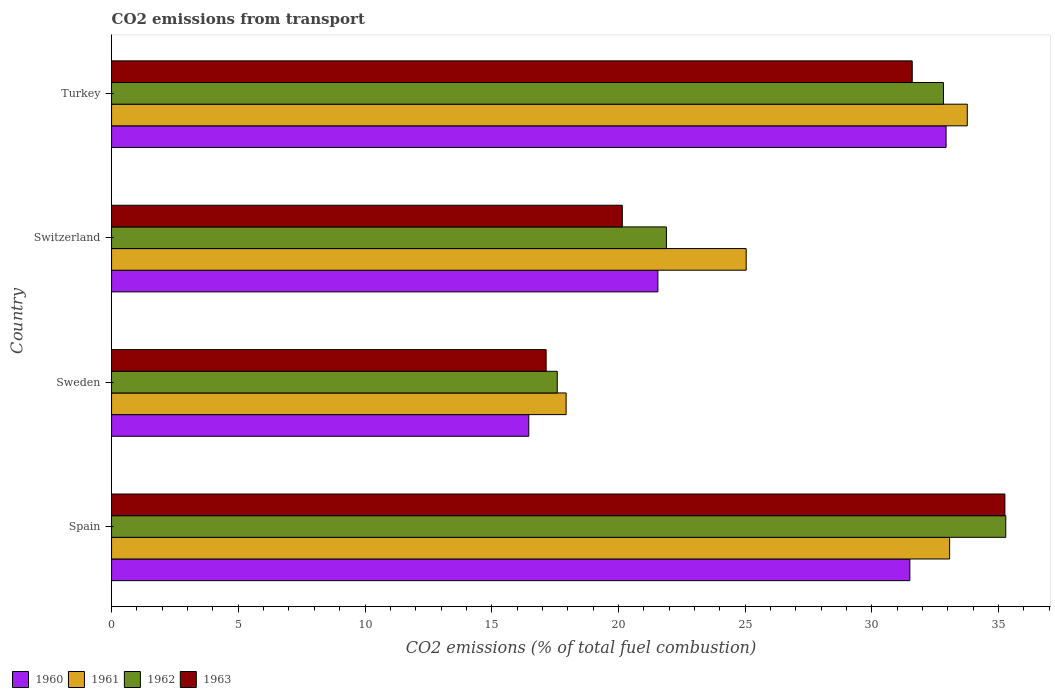How many groups of bars are there?
Make the answer very short. 4. How many bars are there on the 2nd tick from the top?
Your answer should be compact. 4. What is the total CO2 emitted in 1963 in Switzerland?
Your response must be concise. 20.15. Across all countries, what is the maximum total CO2 emitted in 1962?
Provide a succinct answer. 35.28. Across all countries, what is the minimum total CO2 emitted in 1961?
Offer a very short reply. 17.94. What is the total total CO2 emitted in 1960 in the graph?
Give a very brief answer. 102.45. What is the difference between the total CO2 emitted in 1961 in Spain and that in Sweden?
Give a very brief answer. 15.13. What is the difference between the total CO2 emitted in 1962 in Switzerland and the total CO2 emitted in 1960 in Sweden?
Ensure brevity in your answer.  5.43. What is the average total CO2 emitted in 1961 per country?
Ensure brevity in your answer.  27.45. What is the difference between the total CO2 emitted in 1963 and total CO2 emitted in 1960 in Turkey?
Your answer should be very brief. -1.34. What is the ratio of the total CO2 emitted in 1963 in Switzerland to that in Turkey?
Keep it short and to the point. 0.64. What is the difference between the highest and the second highest total CO2 emitted in 1961?
Provide a short and direct response. 0.7. What is the difference between the highest and the lowest total CO2 emitted in 1961?
Give a very brief answer. 15.83. In how many countries, is the total CO2 emitted in 1961 greater than the average total CO2 emitted in 1961 taken over all countries?
Offer a terse response. 2. Is the sum of the total CO2 emitted in 1963 in Spain and Switzerland greater than the maximum total CO2 emitted in 1962 across all countries?
Ensure brevity in your answer.  Yes. Is it the case that in every country, the sum of the total CO2 emitted in 1962 and total CO2 emitted in 1961 is greater than the total CO2 emitted in 1963?
Ensure brevity in your answer.  Yes. How many bars are there?
Provide a short and direct response. 16. Are all the bars in the graph horizontal?
Your answer should be very brief. Yes. What is the difference between two consecutive major ticks on the X-axis?
Ensure brevity in your answer.  5. Does the graph contain any zero values?
Offer a very short reply. No. Does the graph contain grids?
Your response must be concise. No. Where does the legend appear in the graph?
Give a very brief answer. Bottom left. What is the title of the graph?
Your response must be concise. CO2 emissions from transport. What is the label or title of the X-axis?
Your answer should be compact. CO2 emissions (% of total fuel combustion). What is the CO2 emissions (% of total fuel combustion) of 1960 in Spain?
Provide a short and direct response. 31.5. What is the CO2 emissions (% of total fuel combustion) of 1961 in Spain?
Give a very brief answer. 33.07. What is the CO2 emissions (% of total fuel combustion) in 1962 in Spain?
Keep it short and to the point. 35.28. What is the CO2 emissions (% of total fuel combustion) in 1963 in Spain?
Give a very brief answer. 35.25. What is the CO2 emissions (% of total fuel combustion) in 1960 in Sweden?
Offer a very short reply. 16.46. What is the CO2 emissions (% of total fuel combustion) in 1961 in Sweden?
Give a very brief answer. 17.94. What is the CO2 emissions (% of total fuel combustion) in 1962 in Sweden?
Keep it short and to the point. 17.59. What is the CO2 emissions (% of total fuel combustion) in 1963 in Sweden?
Make the answer very short. 17.15. What is the CO2 emissions (% of total fuel combustion) of 1960 in Switzerland?
Your answer should be very brief. 21.56. What is the CO2 emissions (% of total fuel combustion) in 1961 in Switzerland?
Give a very brief answer. 25.04. What is the CO2 emissions (% of total fuel combustion) in 1962 in Switzerland?
Provide a short and direct response. 21.89. What is the CO2 emissions (% of total fuel combustion) of 1963 in Switzerland?
Provide a succinct answer. 20.15. What is the CO2 emissions (% of total fuel combustion) in 1960 in Turkey?
Provide a succinct answer. 32.93. What is the CO2 emissions (% of total fuel combustion) of 1961 in Turkey?
Offer a terse response. 33.76. What is the CO2 emissions (% of total fuel combustion) in 1962 in Turkey?
Provide a short and direct response. 32.82. What is the CO2 emissions (% of total fuel combustion) in 1963 in Turkey?
Your answer should be very brief. 31.59. Across all countries, what is the maximum CO2 emissions (% of total fuel combustion) in 1960?
Ensure brevity in your answer.  32.93. Across all countries, what is the maximum CO2 emissions (% of total fuel combustion) of 1961?
Provide a succinct answer. 33.76. Across all countries, what is the maximum CO2 emissions (% of total fuel combustion) of 1962?
Offer a terse response. 35.28. Across all countries, what is the maximum CO2 emissions (% of total fuel combustion) in 1963?
Provide a short and direct response. 35.25. Across all countries, what is the minimum CO2 emissions (% of total fuel combustion) of 1960?
Your response must be concise. 16.46. Across all countries, what is the minimum CO2 emissions (% of total fuel combustion) of 1961?
Make the answer very short. 17.94. Across all countries, what is the minimum CO2 emissions (% of total fuel combustion) in 1962?
Your answer should be compact. 17.59. Across all countries, what is the minimum CO2 emissions (% of total fuel combustion) of 1963?
Provide a short and direct response. 17.15. What is the total CO2 emissions (% of total fuel combustion) of 1960 in the graph?
Keep it short and to the point. 102.45. What is the total CO2 emissions (% of total fuel combustion) of 1961 in the graph?
Offer a terse response. 109.81. What is the total CO2 emissions (% of total fuel combustion) in 1962 in the graph?
Make the answer very short. 107.59. What is the total CO2 emissions (% of total fuel combustion) of 1963 in the graph?
Give a very brief answer. 104.14. What is the difference between the CO2 emissions (% of total fuel combustion) in 1960 in Spain and that in Sweden?
Make the answer very short. 15.04. What is the difference between the CO2 emissions (% of total fuel combustion) of 1961 in Spain and that in Sweden?
Your response must be concise. 15.13. What is the difference between the CO2 emissions (% of total fuel combustion) in 1962 in Spain and that in Sweden?
Offer a very short reply. 17.7. What is the difference between the CO2 emissions (% of total fuel combustion) of 1963 in Spain and that in Sweden?
Your response must be concise. 18.1. What is the difference between the CO2 emissions (% of total fuel combustion) of 1960 in Spain and that in Switzerland?
Provide a short and direct response. 9.94. What is the difference between the CO2 emissions (% of total fuel combustion) of 1961 in Spain and that in Switzerland?
Give a very brief answer. 8.03. What is the difference between the CO2 emissions (% of total fuel combustion) of 1962 in Spain and that in Switzerland?
Ensure brevity in your answer.  13.39. What is the difference between the CO2 emissions (% of total fuel combustion) in 1963 in Spain and that in Switzerland?
Provide a succinct answer. 15.1. What is the difference between the CO2 emissions (% of total fuel combustion) in 1960 in Spain and that in Turkey?
Your answer should be compact. -1.43. What is the difference between the CO2 emissions (% of total fuel combustion) of 1961 in Spain and that in Turkey?
Provide a short and direct response. -0.7. What is the difference between the CO2 emissions (% of total fuel combustion) of 1962 in Spain and that in Turkey?
Ensure brevity in your answer.  2.46. What is the difference between the CO2 emissions (% of total fuel combustion) in 1963 in Spain and that in Turkey?
Provide a short and direct response. 3.66. What is the difference between the CO2 emissions (% of total fuel combustion) of 1960 in Sweden and that in Switzerland?
Make the answer very short. -5.09. What is the difference between the CO2 emissions (% of total fuel combustion) in 1961 in Sweden and that in Switzerland?
Offer a terse response. -7.1. What is the difference between the CO2 emissions (% of total fuel combustion) in 1962 in Sweden and that in Switzerland?
Provide a short and direct response. -4.31. What is the difference between the CO2 emissions (% of total fuel combustion) in 1963 in Sweden and that in Switzerland?
Provide a succinct answer. -3.01. What is the difference between the CO2 emissions (% of total fuel combustion) in 1960 in Sweden and that in Turkey?
Offer a terse response. -16.47. What is the difference between the CO2 emissions (% of total fuel combustion) of 1961 in Sweden and that in Turkey?
Your response must be concise. -15.83. What is the difference between the CO2 emissions (% of total fuel combustion) of 1962 in Sweden and that in Turkey?
Offer a terse response. -15.24. What is the difference between the CO2 emissions (% of total fuel combustion) in 1963 in Sweden and that in Turkey?
Ensure brevity in your answer.  -14.44. What is the difference between the CO2 emissions (% of total fuel combustion) in 1960 in Switzerland and that in Turkey?
Your answer should be compact. -11.37. What is the difference between the CO2 emissions (% of total fuel combustion) in 1961 in Switzerland and that in Turkey?
Give a very brief answer. -8.72. What is the difference between the CO2 emissions (% of total fuel combustion) of 1962 in Switzerland and that in Turkey?
Make the answer very short. -10.93. What is the difference between the CO2 emissions (% of total fuel combustion) in 1963 in Switzerland and that in Turkey?
Keep it short and to the point. -11.44. What is the difference between the CO2 emissions (% of total fuel combustion) of 1960 in Spain and the CO2 emissions (% of total fuel combustion) of 1961 in Sweden?
Provide a succinct answer. 13.56. What is the difference between the CO2 emissions (% of total fuel combustion) of 1960 in Spain and the CO2 emissions (% of total fuel combustion) of 1962 in Sweden?
Your answer should be compact. 13.91. What is the difference between the CO2 emissions (% of total fuel combustion) of 1960 in Spain and the CO2 emissions (% of total fuel combustion) of 1963 in Sweden?
Your answer should be very brief. 14.35. What is the difference between the CO2 emissions (% of total fuel combustion) in 1961 in Spain and the CO2 emissions (% of total fuel combustion) in 1962 in Sweden?
Provide a short and direct response. 15.48. What is the difference between the CO2 emissions (% of total fuel combustion) in 1961 in Spain and the CO2 emissions (% of total fuel combustion) in 1963 in Sweden?
Provide a short and direct response. 15.92. What is the difference between the CO2 emissions (% of total fuel combustion) of 1962 in Spain and the CO2 emissions (% of total fuel combustion) of 1963 in Sweden?
Offer a very short reply. 18.14. What is the difference between the CO2 emissions (% of total fuel combustion) in 1960 in Spain and the CO2 emissions (% of total fuel combustion) in 1961 in Switzerland?
Give a very brief answer. 6.46. What is the difference between the CO2 emissions (% of total fuel combustion) of 1960 in Spain and the CO2 emissions (% of total fuel combustion) of 1962 in Switzerland?
Your response must be concise. 9.61. What is the difference between the CO2 emissions (% of total fuel combustion) of 1960 in Spain and the CO2 emissions (% of total fuel combustion) of 1963 in Switzerland?
Your answer should be compact. 11.35. What is the difference between the CO2 emissions (% of total fuel combustion) in 1961 in Spain and the CO2 emissions (% of total fuel combustion) in 1962 in Switzerland?
Your answer should be compact. 11.17. What is the difference between the CO2 emissions (% of total fuel combustion) in 1961 in Spain and the CO2 emissions (% of total fuel combustion) in 1963 in Switzerland?
Provide a succinct answer. 12.92. What is the difference between the CO2 emissions (% of total fuel combustion) of 1962 in Spain and the CO2 emissions (% of total fuel combustion) of 1963 in Switzerland?
Offer a very short reply. 15.13. What is the difference between the CO2 emissions (% of total fuel combustion) in 1960 in Spain and the CO2 emissions (% of total fuel combustion) in 1961 in Turkey?
Your answer should be compact. -2.27. What is the difference between the CO2 emissions (% of total fuel combustion) of 1960 in Spain and the CO2 emissions (% of total fuel combustion) of 1962 in Turkey?
Ensure brevity in your answer.  -1.33. What is the difference between the CO2 emissions (% of total fuel combustion) of 1960 in Spain and the CO2 emissions (% of total fuel combustion) of 1963 in Turkey?
Offer a terse response. -0.09. What is the difference between the CO2 emissions (% of total fuel combustion) in 1961 in Spain and the CO2 emissions (% of total fuel combustion) in 1962 in Turkey?
Ensure brevity in your answer.  0.24. What is the difference between the CO2 emissions (% of total fuel combustion) in 1961 in Spain and the CO2 emissions (% of total fuel combustion) in 1963 in Turkey?
Give a very brief answer. 1.48. What is the difference between the CO2 emissions (% of total fuel combustion) in 1962 in Spain and the CO2 emissions (% of total fuel combustion) in 1963 in Turkey?
Give a very brief answer. 3.69. What is the difference between the CO2 emissions (% of total fuel combustion) in 1960 in Sweden and the CO2 emissions (% of total fuel combustion) in 1961 in Switzerland?
Offer a very short reply. -8.58. What is the difference between the CO2 emissions (% of total fuel combustion) of 1960 in Sweden and the CO2 emissions (% of total fuel combustion) of 1962 in Switzerland?
Provide a succinct answer. -5.43. What is the difference between the CO2 emissions (% of total fuel combustion) in 1960 in Sweden and the CO2 emissions (% of total fuel combustion) in 1963 in Switzerland?
Offer a very short reply. -3.69. What is the difference between the CO2 emissions (% of total fuel combustion) in 1961 in Sweden and the CO2 emissions (% of total fuel combustion) in 1962 in Switzerland?
Provide a succinct answer. -3.96. What is the difference between the CO2 emissions (% of total fuel combustion) of 1961 in Sweden and the CO2 emissions (% of total fuel combustion) of 1963 in Switzerland?
Keep it short and to the point. -2.22. What is the difference between the CO2 emissions (% of total fuel combustion) of 1962 in Sweden and the CO2 emissions (% of total fuel combustion) of 1963 in Switzerland?
Offer a terse response. -2.57. What is the difference between the CO2 emissions (% of total fuel combustion) of 1960 in Sweden and the CO2 emissions (% of total fuel combustion) of 1961 in Turkey?
Offer a terse response. -17.3. What is the difference between the CO2 emissions (% of total fuel combustion) of 1960 in Sweden and the CO2 emissions (% of total fuel combustion) of 1962 in Turkey?
Provide a succinct answer. -16.36. What is the difference between the CO2 emissions (% of total fuel combustion) of 1960 in Sweden and the CO2 emissions (% of total fuel combustion) of 1963 in Turkey?
Offer a very short reply. -15.13. What is the difference between the CO2 emissions (% of total fuel combustion) in 1961 in Sweden and the CO2 emissions (% of total fuel combustion) in 1962 in Turkey?
Provide a short and direct response. -14.89. What is the difference between the CO2 emissions (% of total fuel combustion) of 1961 in Sweden and the CO2 emissions (% of total fuel combustion) of 1963 in Turkey?
Give a very brief answer. -13.66. What is the difference between the CO2 emissions (% of total fuel combustion) of 1962 in Sweden and the CO2 emissions (% of total fuel combustion) of 1963 in Turkey?
Your answer should be compact. -14.01. What is the difference between the CO2 emissions (% of total fuel combustion) in 1960 in Switzerland and the CO2 emissions (% of total fuel combustion) in 1961 in Turkey?
Provide a short and direct response. -12.21. What is the difference between the CO2 emissions (% of total fuel combustion) in 1960 in Switzerland and the CO2 emissions (% of total fuel combustion) in 1962 in Turkey?
Make the answer very short. -11.27. What is the difference between the CO2 emissions (% of total fuel combustion) of 1960 in Switzerland and the CO2 emissions (% of total fuel combustion) of 1963 in Turkey?
Ensure brevity in your answer.  -10.04. What is the difference between the CO2 emissions (% of total fuel combustion) in 1961 in Switzerland and the CO2 emissions (% of total fuel combustion) in 1962 in Turkey?
Your answer should be compact. -7.78. What is the difference between the CO2 emissions (% of total fuel combustion) in 1961 in Switzerland and the CO2 emissions (% of total fuel combustion) in 1963 in Turkey?
Keep it short and to the point. -6.55. What is the difference between the CO2 emissions (% of total fuel combustion) of 1962 in Switzerland and the CO2 emissions (% of total fuel combustion) of 1963 in Turkey?
Offer a terse response. -9.7. What is the average CO2 emissions (% of total fuel combustion) in 1960 per country?
Your response must be concise. 25.61. What is the average CO2 emissions (% of total fuel combustion) of 1961 per country?
Offer a very short reply. 27.45. What is the average CO2 emissions (% of total fuel combustion) in 1962 per country?
Offer a terse response. 26.9. What is the average CO2 emissions (% of total fuel combustion) of 1963 per country?
Your answer should be very brief. 26.03. What is the difference between the CO2 emissions (% of total fuel combustion) in 1960 and CO2 emissions (% of total fuel combustion) in 1961 in Spain?
Ensure brevity in your answer.  -1.57. What is the difference between the CO2 emissions (% of total fuel combustion) in 1960 and CO2 emissions (% of total fuel combustion) in 1962 in Spain?
Make the answer very short. -3.78. What is the difference between the CO2 emissions (% of total fuel combustion) in 1960 and CO2 emissions (% of total fuel combustion) in 1963 in Spain?
Provide a short and direct response. -3.75. What is the difference between the CO2 emissions (% of total fuel combustion) in 1961 and CO2 emissions (% of total fuel combustion) in 1962 in Spain?
Provide a short and direct response. -2.22. What is the difference between the CO2 emissions (% of total fuel combustion) of 1961 and CO2 emissions (% of total fuel combustion) of 1963 in Spain?
Provide a short and direct response. -2.18. What is the difference between the CO2 emissions (% of total fuel combustion) of 1962 and CO2 emissions (% of total fuel combustion) of 1963 in Spain?
Offer a very short reply. 0.04. What is the difference between the CO2 emissions (% of total fuel combustion) in 1960 and CO2 emissions (% of total fuel combustion) in 1961 in Sweden?
Offer a very short reply. -1.47. What is the difference between the CO2 emissions (% of total fuel combustion) in 1960 and CO2 emissions (% of total fuel combustion) in 1962 in Sweden?
Your answer should be very brief. -1.12. What is the difference between the CO2 emissions (% of total fuel combustion) in 1960 and CO2 emissions (% of total fuel combustion) in 1963 in Sweden?
Ensure brevity in your answer.  -0.69. What is the difference between the CO2 emissions (% of total fuel combustion) of 1961 and CO2 emissions (% of total fuel combustion) of 1962 in Sweden?
Your response must be concise. 0.35. What is the difference between the CO2 emissions (% of total fuel combustion) in 1961 and CO2 emissions (% of total fuel combustion) in 1963 in Sweden?
Make the answer very short. 0.79. What is the difference between the CO2 emissions (% of total fuel combustion) of 1962 and CO2 emissions (% of total fuel combustion) of 1963 in Sweden?
Your response must be concise. 0.44. What is the difference between the CO2 emissions (% of total fuel combustion) in 1960 and CO2 emissions (% of total fuel combustion) in 1961 in Switzerland?
Keep it short and to the point. -3.48. What is the difference between the CO2 emissions (% of total fuel combustion) of 1960 and CO2 emissions (% of total fuel combustion) of 1962 in Switzerland?
Provide a short and direct response. -0.34. What is the difference between the CO2 emissions (% of total fuel combustion) in 1960 and CO2 emissions (% of total fuel combustion) in 1963 in Switzerland?
Offer a very short reply. 1.4. What is the difference between the CO2 emissions (% of total fuel combustion) of 1961 and CO2 emissions (% of total fuel combustion) of 1962 in Switzerland?
Provide a succinct answer. 3.15. What is the difference between the CO2 emissions (% of total fuel combustion) of 1961 and CO2 emissions (% of total fuel combustion) of 1963 in Switzerland?
Offer a terse response. 4.89. What is the difference between the CO2 emissions (% of total fuel combustion) of 1962 and CO2 emissions (% of total fuel combustion) of 1963 in Switzerland?
Provide a succinct answer. 1.74. What is the difference between the CO2 emissions (% of total fuel combustion) of 1960 and CO2 emissions (% of total fuel combustion) of 1961 in Turkey?
Offer a terse response. -0.84. What is the difference between the CO2 emissions (% of total fuel combustion) in 1960 and CO2 emissions (% of total fuel combustion) in 1962 in Turkey?
Your response must be concise. 0.1. What is the difference between the CO2 emissions (% of total fuel combustion) in 1960 and CO2 emissions (% of total fuel combustion) in 1963 in Turkey?
Your response must be concise. 1.34. What is the difference between the CO2 emissions (% of total fuel combustion) in 1961 and CO2 emissions (% of total fuel combustion) in 1962 in Turkey?
Offer a very short reply. 0.94. What is the difference between the CO2 emissions (% of total fuel combustion) of 1961 and CO2 emissions (% of total fuel combustion) of 1963 in Turkey?
Ensure brevity in your answer.  2.17. What is the difference between the CO2 emissions (% of total fuel combustion) in 1962 and CO2 emissions (% of total fuel combustion) in 1963 in Turkey?
Ensure brevity in your answer.  1.23. What is the ratio of the CO2 emissions (% of total fuel combustion) of 1960 in Spain to that in Sweden?
Make the answer very short. 1.91. What is the ratio of the CO2 emissions (% of total fuel combustion) of 1961 in Spain to that in Sweden?
Your response must be concise. 1.84. What is the ratio of the CO2 emissions (% of total fuel combustion) in 1962 in Spain to that in Sweden?
Your response must be concise. 2.01. What is the ratio of the CO2 emissions (% of total fuel combustion) of 1963 in Spain to that in Sweden?
Offer a very short reply. 2.06. What is the ratio of the CO2 emissions (% of total fuel combustion) in 1960 in Spain to that in Switzerland?
Make the answer very short. 1.46. What is the ratio of the CO2 emissions (% of total fuel combustion) in 1961 in Spain to that in Switzerland?
Your response must be concise. 1.32. What is the ratio of the CO2 emissions (% of total fuel combustion) of 1962 in Spain to that in Switzerland?
Your answer should be compact. 1.61. What is the ratio of the CO2 emissions (% of total fuel combustion) of 1963 in Spain to that in Switzerland?
Ensure brevity in your answer.  1.75. What is the ratio of the CO2 emissions (% of total fuel combustion) in 1960 in Spain to that in Turkey?
Your response must be concise. 0.96. What is the ratio of the CO2 emissions (% of total fuel combustion) in 1961 in Spain to that in Turkey?
Provide a short and direct response. 0.98. What is the ratio of the CO2 emissions (% of total fuel combustion) in 1962 in Spain to that in Turkey?
Your answer should be very brief. 1.07. What is the ratio of the CO2 emissions (% of total fuel combustion) of 1963 in Spain to that in Turkey?
Give a very brief answer. 1.12. What is the ratio of the CO2 emissions (% of total fuel combustion) of 1960 in Sweden to that in Switzerland?
Your response must be concise. 0.76. What is the ratio of the CO2 emissions (% of total fuel combustion) of 1961 in Sweden to that in Switzerland?
Your answer should be compact. 0.72. What is the ratio of the CO2 emissions (% of total fuel combustion) of 1962 in Sweden to that in Switzerland?
Offer a terse response. 0.8. What is the ratio of the CO2 emissions (% of total fuel combustion) of 1963 in Sweden to that in Switzerland?
Offer a terse response. 0.85. What is the ratio of the CO2 emissions (% of total fuel combustion) of 1960 in Sweden to that in Turkey?
Make the answer very short. 0.5. What is the ratio of the CO2 emissions (% of total fuel combustion) of 1961 in Sweden to that in Turkey?
Provide a succinct answer. 0.53. What is the ratio of the CO2 emissions (% of total fuel combustion) in 1962 in Sweden to that in Turkey?
Your answer should be compact. 0.54. What is the ratio of the CO2 emissions (% of total fuel combustion) of 1963 in Sweden to that in Turkey?
Ensure brevity in your answer.  0.54. What is the ratio of the CO2 emissions (% of total fuel combustion) of 1960 in Switzerland to that in Turkey?
Give a very brief answer. 0.65. What is the ratio of the CO2 emissions (% of total fuel combustion) of 1961 in Switzerland to that in Turkey?
Offer a very short reply. 0.74. What is the ratio of the CO2 emissions (% of total fuel combustion) in 1962 in Switzerland to that in Turkey?
Ensure brevity in your answer.  0.67. What is the ratio of the CO2 emissions (% of total fuel combustion) in 1963 in Switzerland to that in Turkey?
Your answer should be very brief. 0.64. What is the difference between the highest and the second highest CO2 emissions (% of total fuel combustion) in 1960?
Give a very brief answer. 1.43. What is the difference between the highest and the second highest CO2 emissions (% of total fuel combustion) of 1961?
Keep it short and to the point. 0.7. What is the difference between the highest and the second highest CO2 emissions (% of total fuel combustion) in 1962?
Your answer should be very brief. 2.46. What is the difference between the highest and the second highest CO2 emissions (% of total fuel combustion) in 1963?
Your response must be concise. 3.66. What is the difference between the highest and the lowest CO2 emissions (% of total fuel combustion) of 1960?
Offer a very short reply. 16.47. What is the difference between the highest and the lowest CO2 emissions (% of total fuel combustion) in 1961?
Offer a terse response. 15.83. What is the difference between the highest and the lowest CO2 emissions (% of total fuel combustion) of 1962?
Give a very brief answer. 17.7. What is the difference between the highest and the lowest CO2 emissions (% of total fuel combustion) in 1963?
Your answer should be compact. 18.1. 